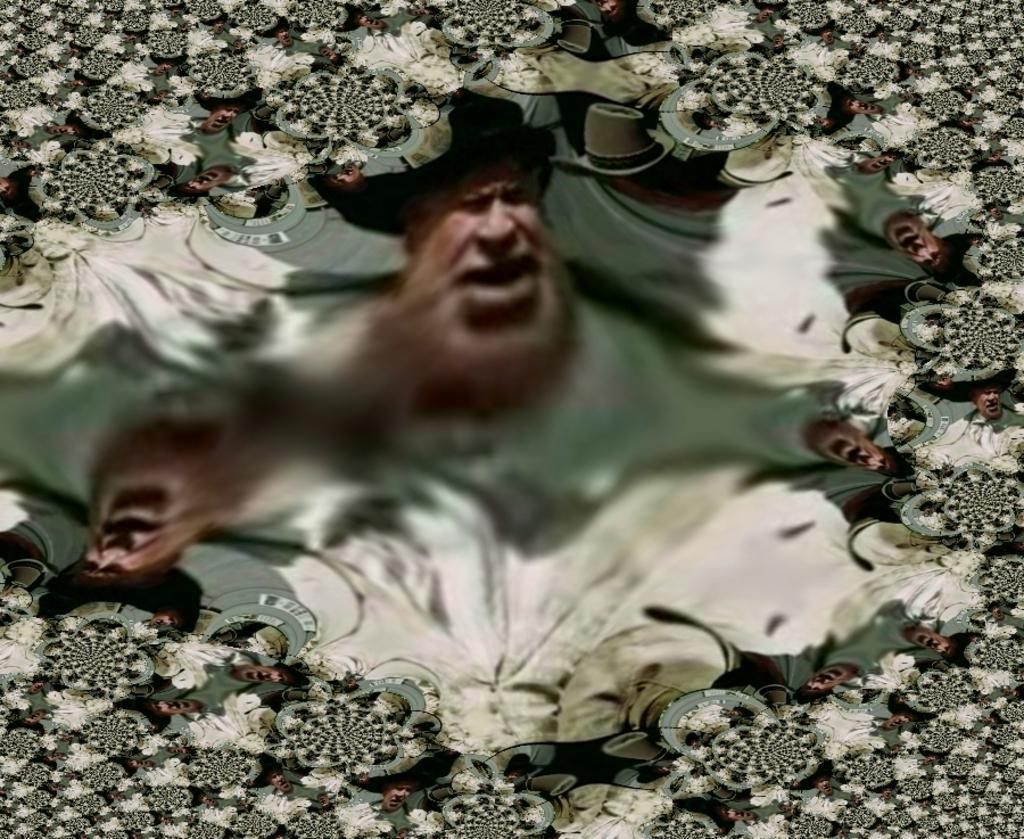Please provide a concise description of this image. In the picture there are many photos of a person present. 